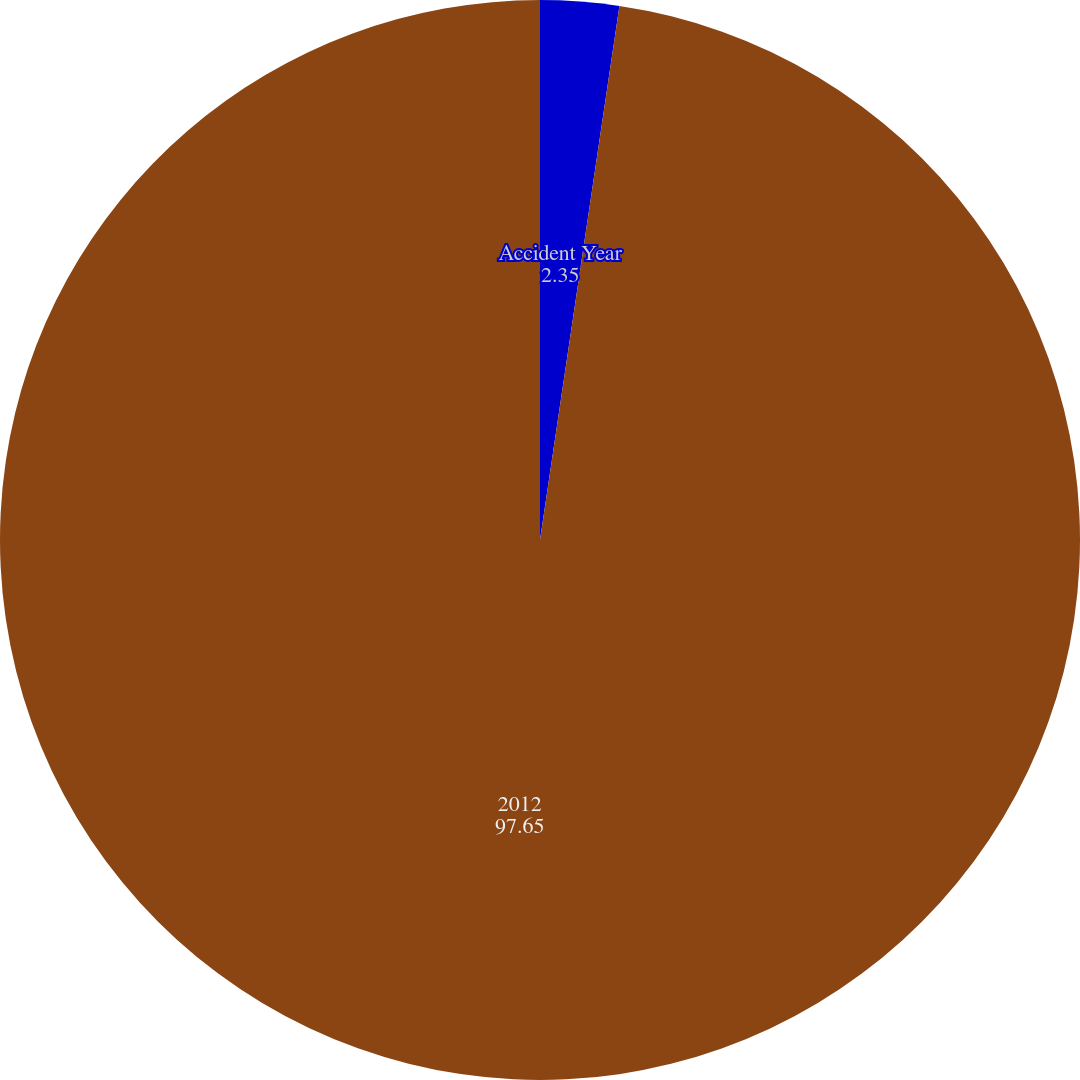Convert chart to OTSL. <chart><loc_0><loc_0><loc_500><loc_500><pie_chart><fcel>Accident Year<fcel>2012<nl><fcel>2.35%<fcel>97.65%<nl></chart> 